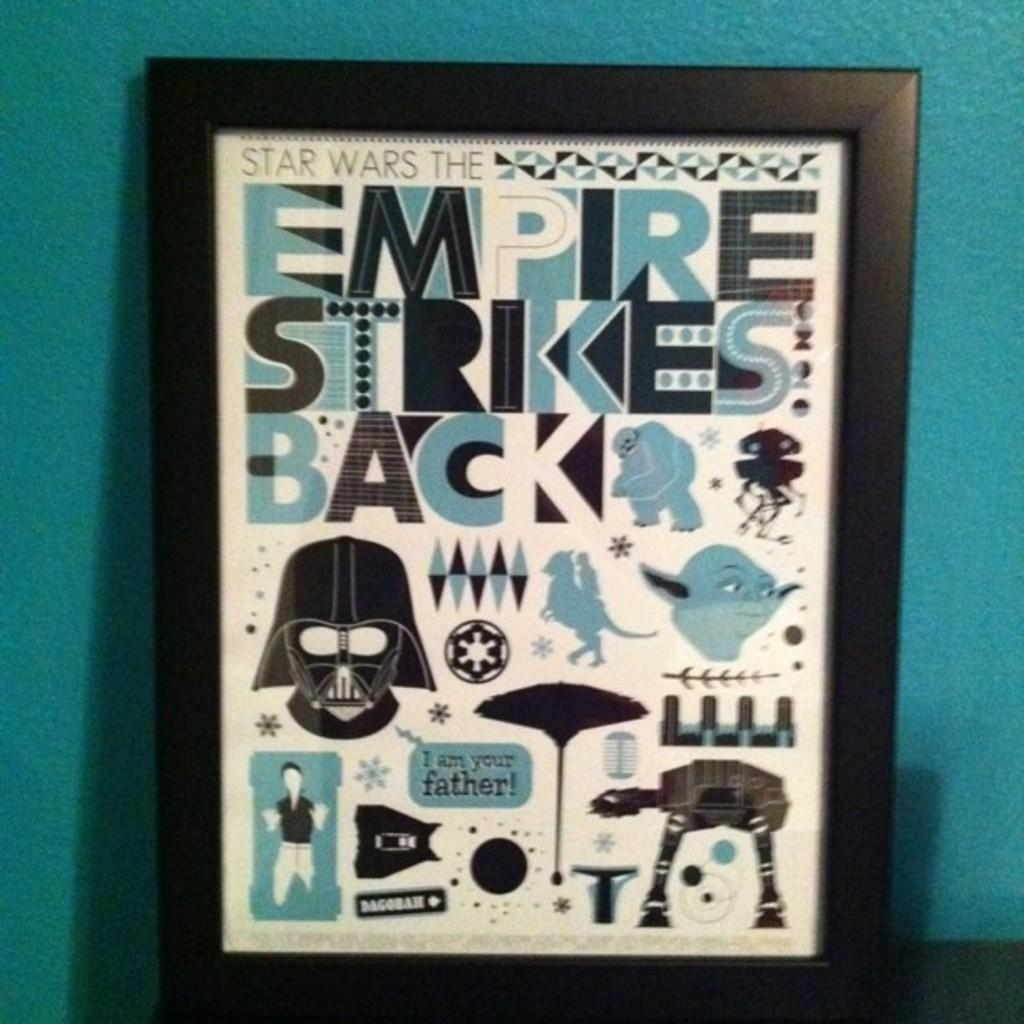<image>
Share a concise interpretation of the image provided. Picture frame that shows Star Wars characters and the words "I Am Your Father" next to one. 